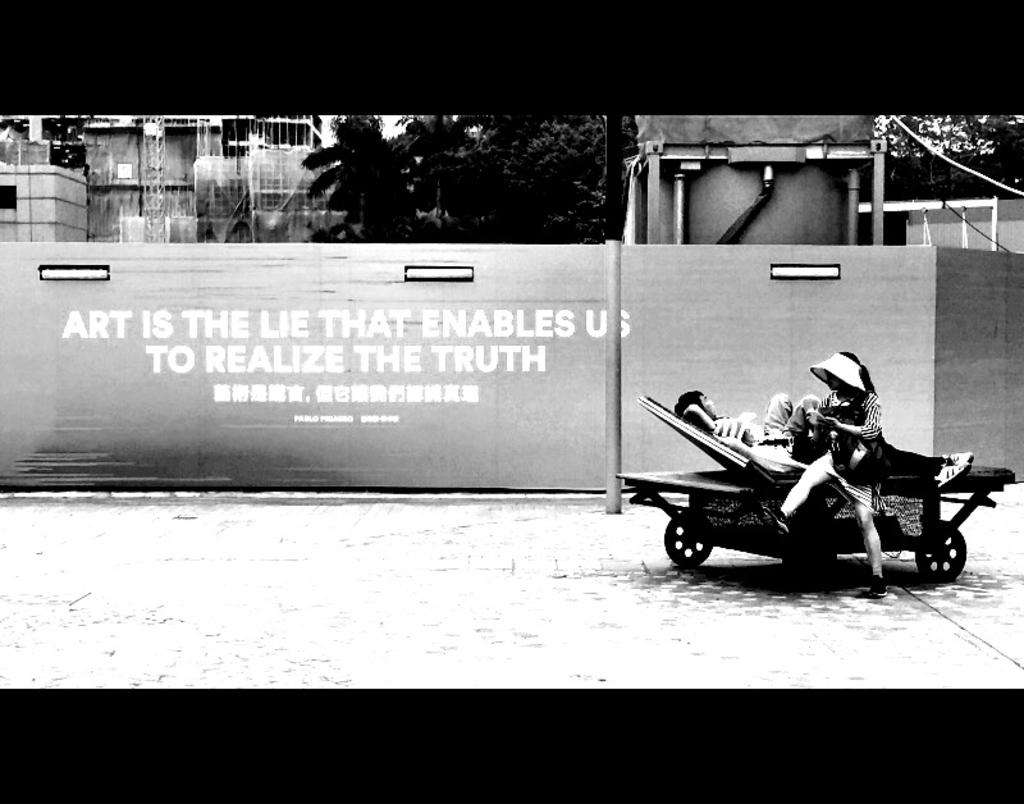How many people are sitting on the trolley in the image? There are two persons sitting on a trolley in the image. What can be seen in the background of the image? In the background of the image, there is a fence, trees, metal rods, and buildings. What type of structure is the trolley likely to be found in? The trolley might be found in an amusement park or a similar recreational area. How is the image presented? The image appears to be in a photo frame. What type of yam is being used to heal the wound on the person's leg in the image? There is no yam or wound present in the image; it features two persons sitting on a trolley with a background of various structures. How many team members are visible in the image? There is no team or team members present in the image. 